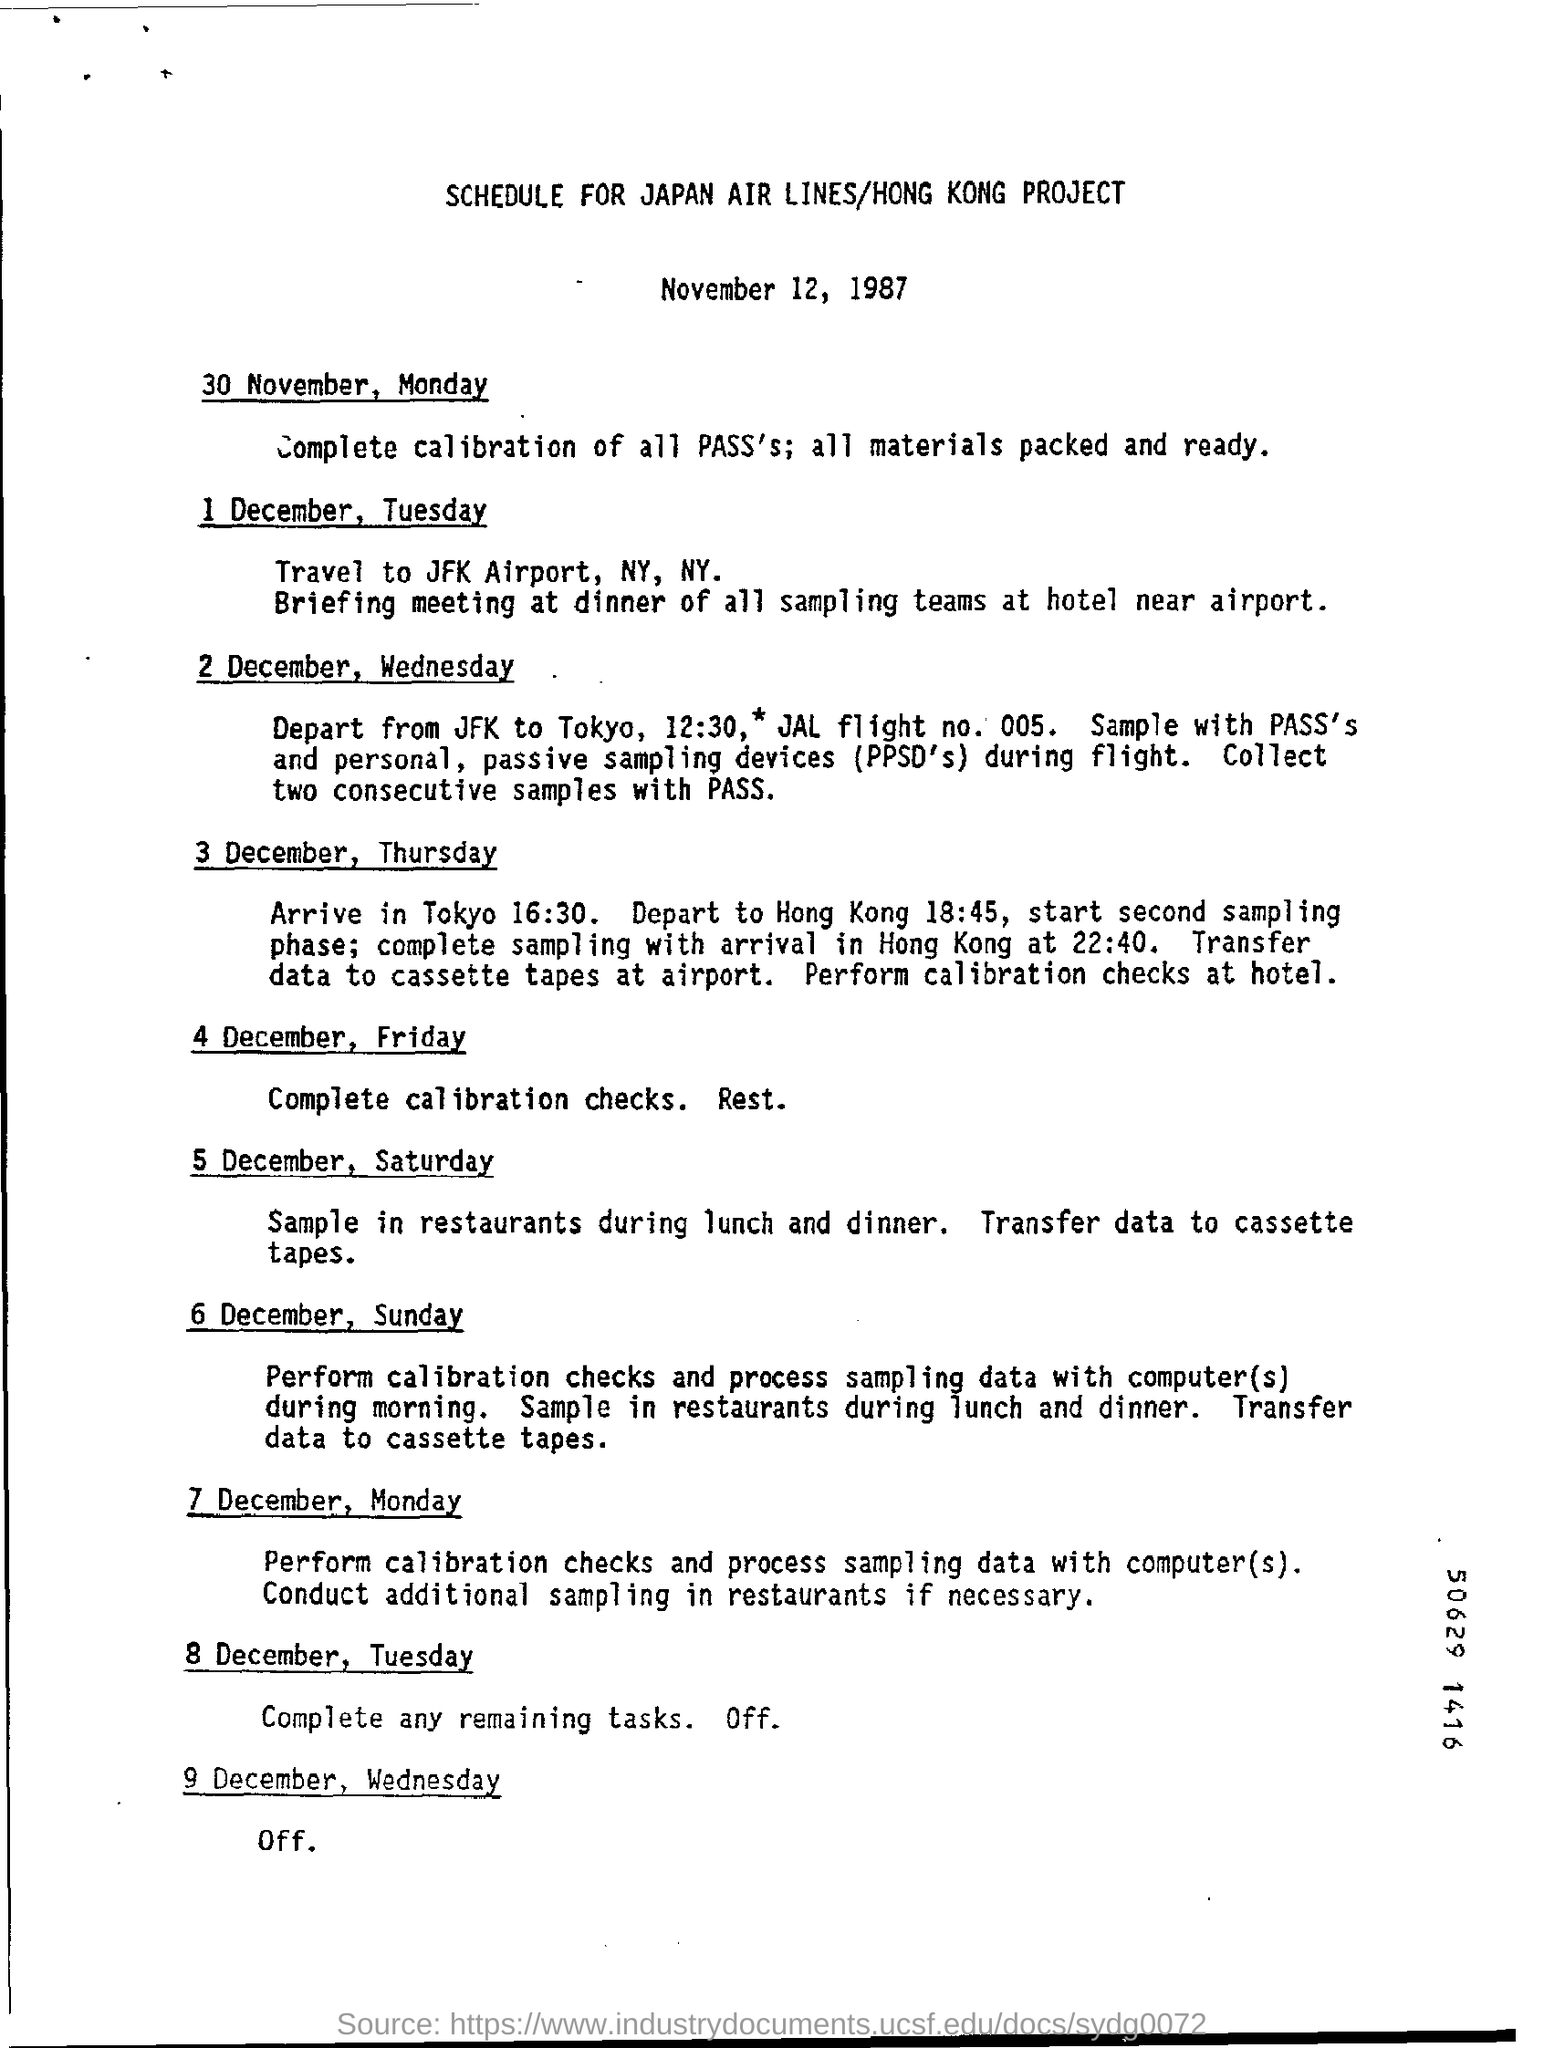Highlight a few significant elements in this photo. The given document is titled "Schedule for Japan Airlines/Hong Kong Project. The departure time from JFK Airport to Tokyo is 12:30 PM. 